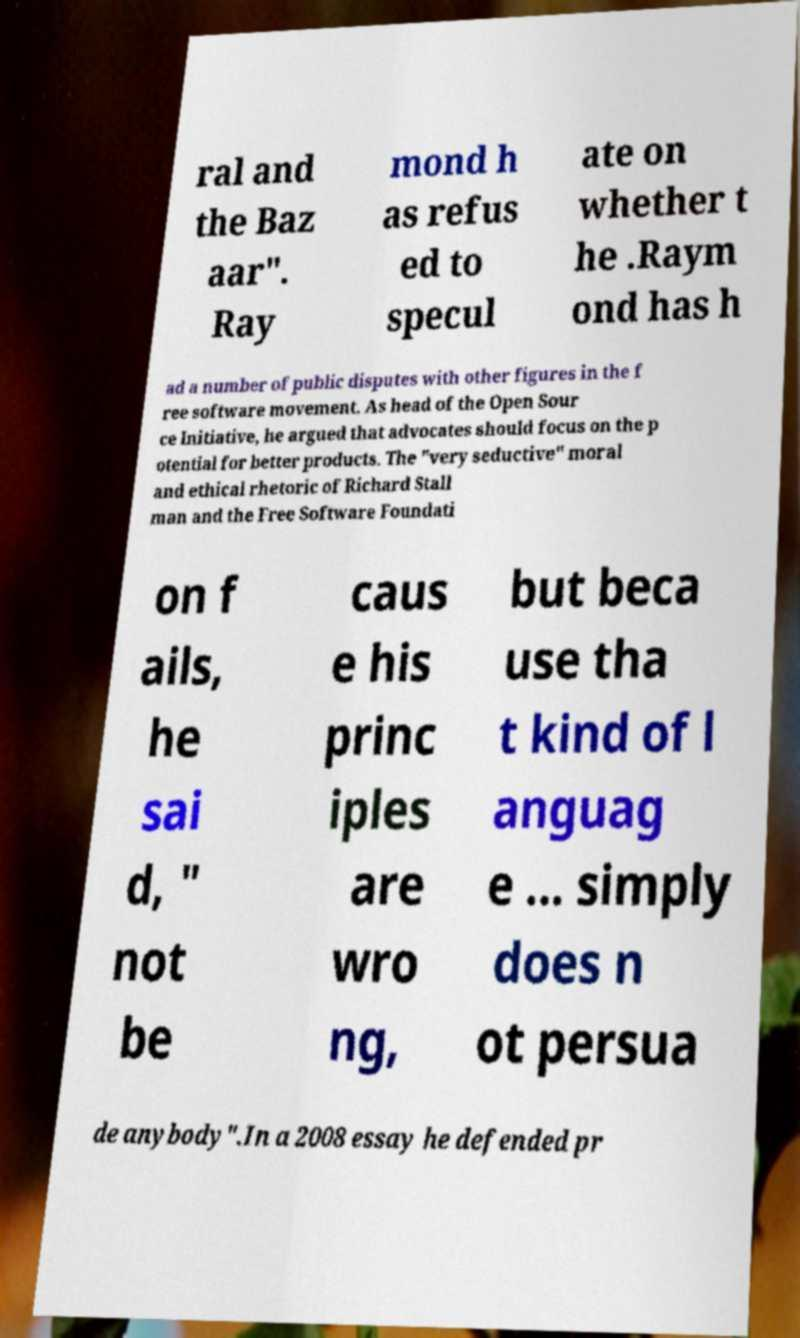Please identify and transcribe the text found in this image. ral and the Baz aar". Ray mond h as refus ed to specul ate on whether t he .Raym ond has h ad a number of public disputes with other figures in the f ree software movement. As head of the Open Sour ce Initiative, he argued that advocates should focus on the p otential for better products. The "very seductive" moral and ethical rhetoric of Richard Stall man and the Free Software Foundati on f ails, he sai d, " not be caus e his princ iples are wro ng, but beca use tha t kind of l anguag e ... simply does n ot persua de anybody".In a 2008 essay he defended pr 